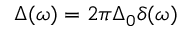Convert formula to latex. <formula><loc_0><loc_0><loc_500><loc_500>\Delta ( \omega ) = 2 \pi \Delta _ { 0 } \delta ( \omega )</formula> 